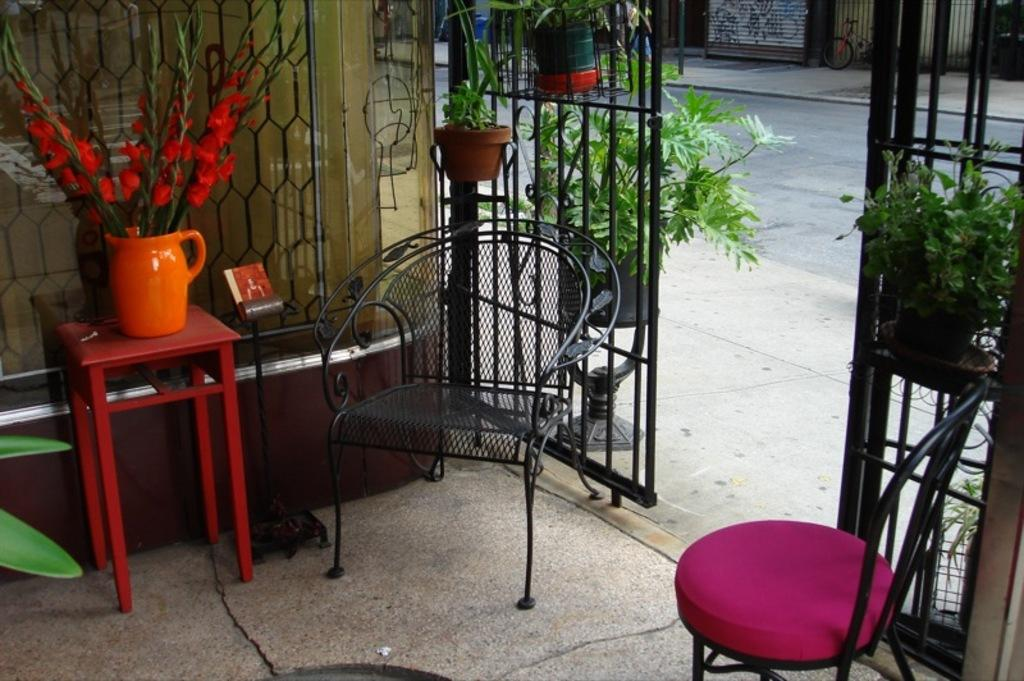What type of furniture is visible in the image? There are chairs and a table in the image. What is placed on the table? A flower vase is placed on the table. What architectural feature can be seen in the image? There is a gate in the image. What type of decorative items are present in the image? Flower pots are present in the image. What type of quilt is draped over the chairs in the image? There is no quilt present in the image; only chairs, a table, a flower vase, a gate, and flower pots are visible. Is the image taken during a camping trip? There is no indication of a camping trip in the image; it features chairs, a table, a flower vase, a gate, and flower pots. 